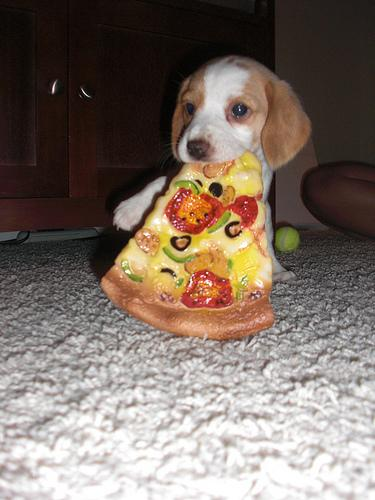Explain the position of an olive in the image. A sliced black olive is on the pizza slice. Identify the primary object in the image and its action. A white and brown puppy is eating a slice of pizza. What type of ball can be found on the floor? A green tennis ball. Identify the material and position of the cabinet in the image. A wooden cabinet is on the carpet. Count the number of dog's ears visible in the image. Two ears are visible. What type of object is under the cabinet and what color is it? A gray power strip is under the cabinet. Name the ingredients visible on the pizza slice. Black olives, green peppers, and tomato slices can be seen. How many eyes of the dog can be seen, and what is their color? Two eyes can be seen, and they are blue. Describe any human body part visible in the image and its state. A person's folded leg is visible. Detail the appearance of the carpet and its color. The carpet is white and brown. 